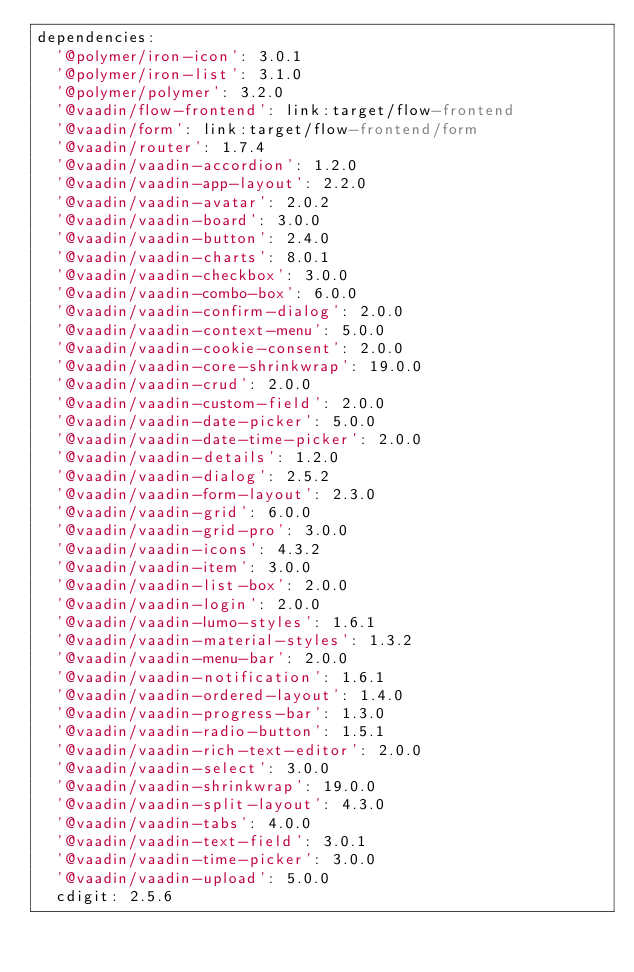Convert code to text. <code><loc_0><loc_0><loc_500><loc_500><_YAML_>dependencies:
  '@polymer/iron-icon': 3.0.1
  '@polymer/iron-list': 3.1.0
  '@polymer/polymer': 3.2.0
  '@vaadin/flow-frontend': link:target/flow-frontend
  '@vaadin/form': link:target/flow-frontend/form
  '@vaadin/router': 1.7.4
  '@vaadin/vaadin-accordion': 1.2.0
  '@vaadin/vaadin-app-layout': 2.2.0
  '@vaadin/vaadin-avatar': 2.0.2
  '@vaadin/vaadin-board': 3.0.0
  '@vaadin/vaadin-button': 2.4.0
  '@vaadin/vaadin-charts': 8.0.1
  '@vaadin/vaadin-checkbox': 3.0.0
  '@vaadin/vaadin-combo-box': 6.0.0
  '@vaadin/vaadin-confirm-dialog': 2.0.0
  '@vaadin/vaadin-context-menu': 5.0.0
  '@vaadin/vaadin-cookie-consent': 2.0.0
  '@vaadin/vaadin-core-shrinkwrap': 19.0.0
  '@vaadin/vaadin-crud': 2.0.0
  '@vaadin/vaadin-custom-field': 2.0.0
  '@vaadin/vaadin-date-picker': 5.0.0
  '@vaadin/vaadin-date-time-picker': 2.0.0
  '@vaadin/vaadin-details': 1.2.0
  '@vaadin/vaadin-dialog': 2.5.2
  '@vaadin/vaadin-form-layout': 2.3.0
  '@vaadin/vaadin-grid': 6.0.0
  '@vaadin/vaadin-grid-pro': 3.0.0
  '@vaadin/vaadin-icons': 4.3.2
  '@vaadin/vaadin-item': 3.0.0
  '@vaadin/vaadin-list-box': 2.0.0
  '@vaadin/vaadin-login': 2.0.0
  '@vaadin/vaadin-lumo-styles': 1.6.1
  '@vaadin/vaadin-material-styles': 1.3.2
  '@vaadin/vaadin-menu-bar': 2.0.0
  '@vaadin/vaadin-notification': 1.6.1
  '@vaadin/vaadin-ordered-layout': 1.4.0
  '@vaadin/vaadin-progress-bar': 1.3.0
  '@vaadin/vaadin-radio-button': 1.5.1
  '@vaadin/vaadin-rich-text-editor': 2.0.0
  '@vaadin/vaadin-select': 3.0.0
  '@vaadin/vaadin-shrinkwrap': 19.0.0
  '@vaadin/vaadin-split-layout': 4.3.0
  '@vaadin/vaadin-tabs': 4.0.0
  '@vaadin/vaadin-text-field': 3.0.1
  '@vaadin/vaadin-time-picker': 3.0.0
  '@vaadin/vaadin-upload': 5.0.0
  cdigit: 2.5.6</code> 